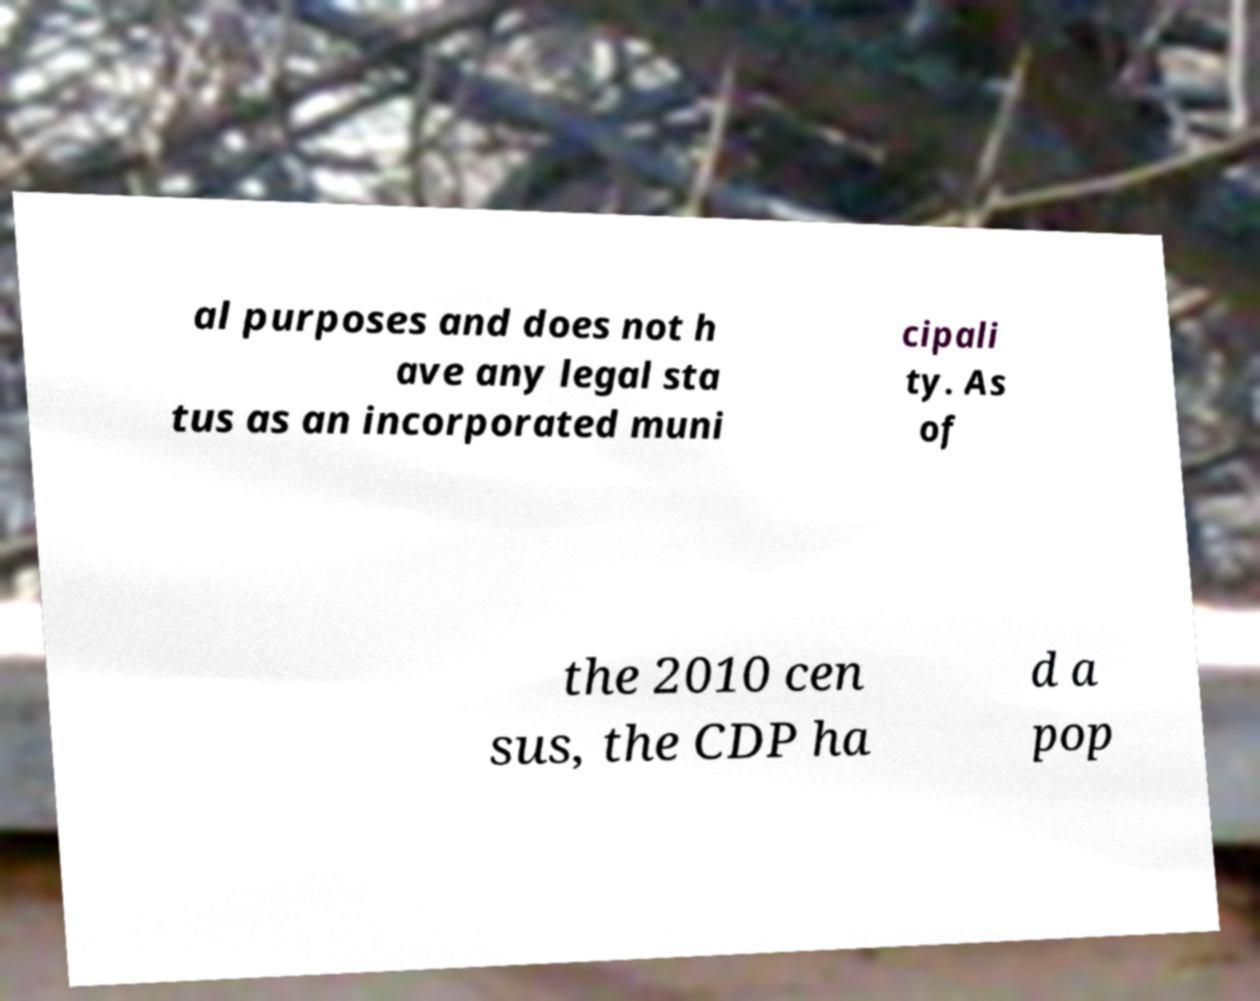Could you extract and type out the text from this image? al purposes and does not h ave any legal sta tus as an incorporated muni cipali ty. As of the 2010 cen sus, the CDP ha d a pop 